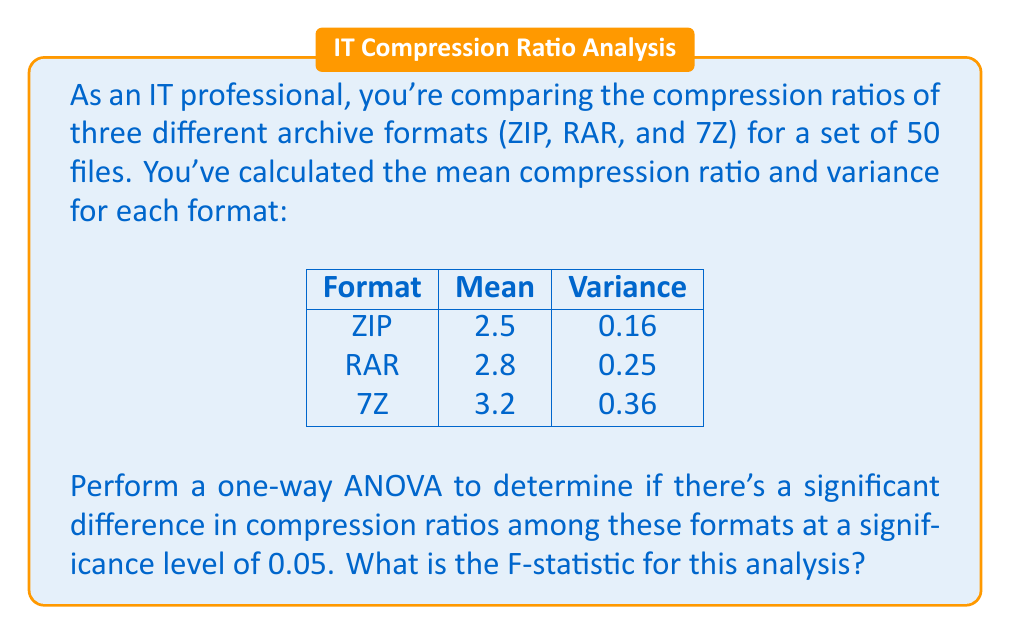Provide a solution to this math problem. To perform a one-way ANOVA and calculate the F-statistic, we'll follow these steps:

1. Calculate the Sum of Squares Between groups (SSB):
   $$SSB = n \sum_{i=1}^k (\bar{x}_i - \bar{x})^2$$
   where $n$ is the number of observations in each group, $k$ is the number of groups, $\bar{x}_i$ is the mean of each group, and $\bar{x}$ is the grand mean.

2. Calculate the Sum of Squares Within groups (SSW):
   $$SSW = (n-1) \sum_{i=1}^k s_i^2$$
   where $s_i^2$ is the variance of each group.

3. Calculate the degrees of freedom:
   $$df_{between} = k - 1$$
   $$df_{within} = k(n-1)$$

4. Calculate the Mean Square Between (MSB) and Mean Square Within (MSW):
   $$MSB = \frac{SSB}{df_{between}}$$
   $$MSW = \frac{SSW}{df_{within}}$$

5. Calculate the F-statistic:
   $$F = \frac{MSB}{MSW}$$

Now, let's apply these steps to our problem:

1. Calculate the grand mean:
   $$\bar{x} = \frac{2.5 + 2.8 + 3.2}{3} = 2.833$$

2. Calculate SSB:
   $$SSB = 50 [(2.5 - 2.833)^2 + (2.8 - 2.833)^2 + (3.2 - 2.833)^2] = 12.25$$

3. Calculate SSW:
   $$SSW = 49(0.16 + 0.25 + 0.36) = 37.73$$

4. Calculate degrees of freedom:
   $$df_{between} = 3 - 1 = 2$$
   $$df_{within} = 3(50 - 1) = 147$$

5. Calculate MSB and MSW:
   $$MSB = \frac{12.25}{2} = 6.125$$
   $$MSW = \frac{37.73}{147} = 0.2566$$

6. Calculate the F-statistic:
   $$F = \frac{6.125}{0.2566} = 23.87$$

Therefore, the F-statistic for this analysis is 23.87.
Answer: 23.87 